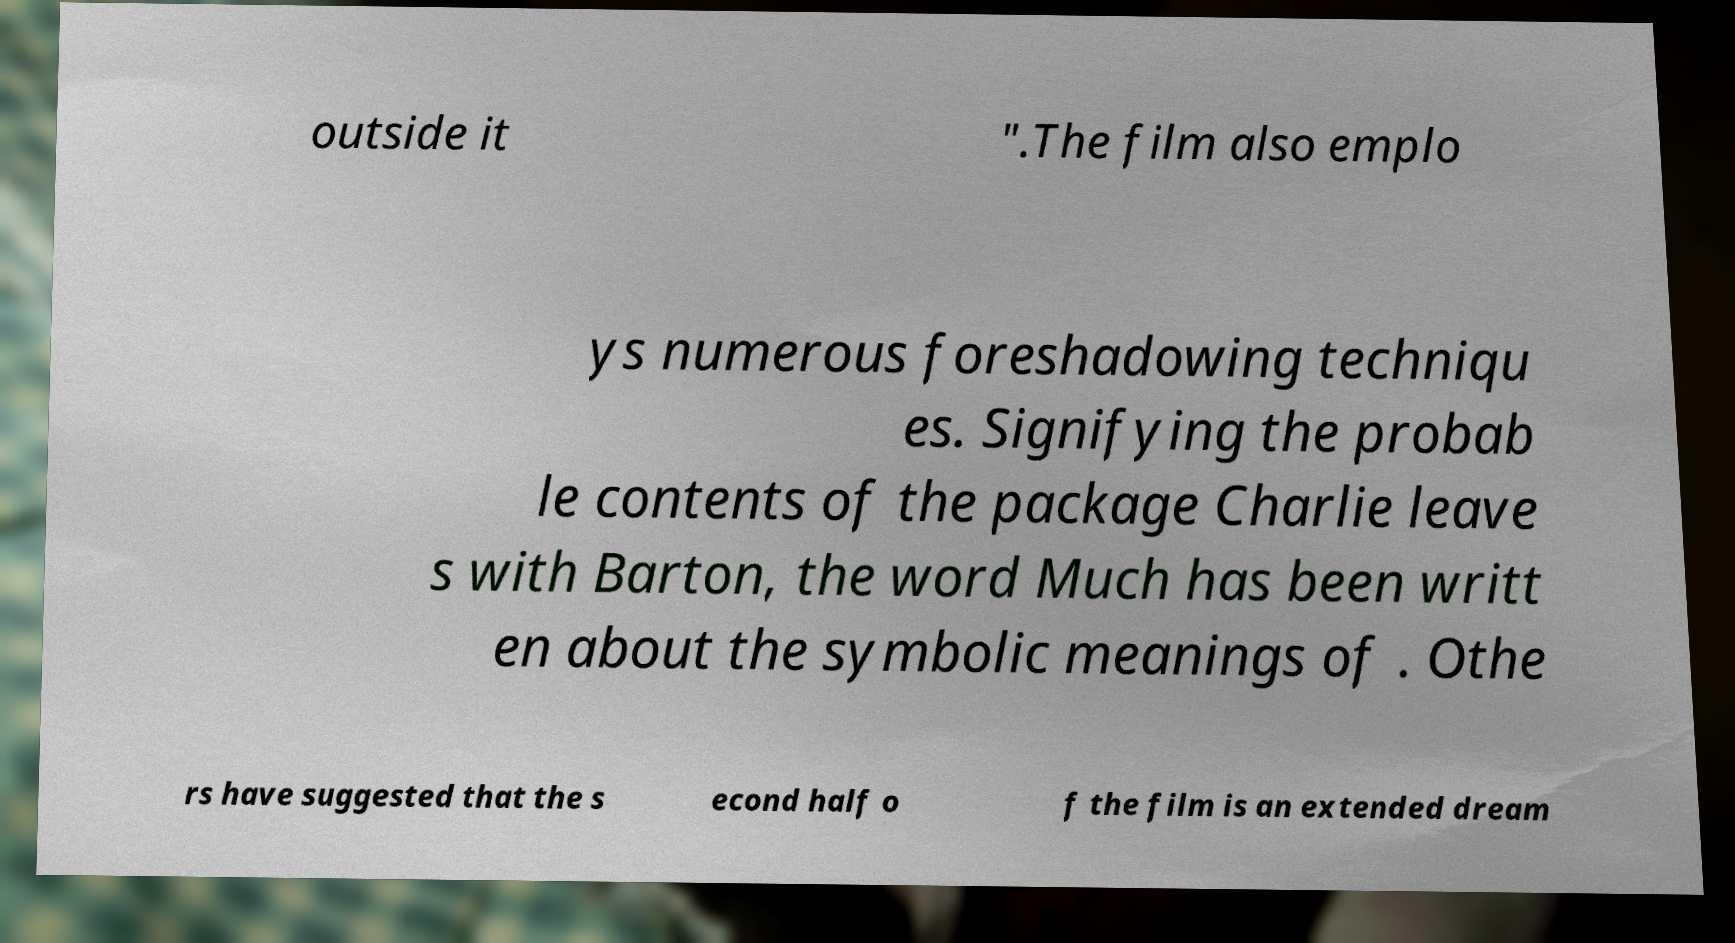For documentation purposes, I need the text within this image transcribed. Could you provide that? outside it ".The film also emplo ys numerous foreshadowing techniqu es. Signifying the probab le contents of the package Charlie leave s with Barton, the word Much has been writt en about the symbolic meanings of . Othe rs have suggested that the s econd half o f the film is an extended dream 